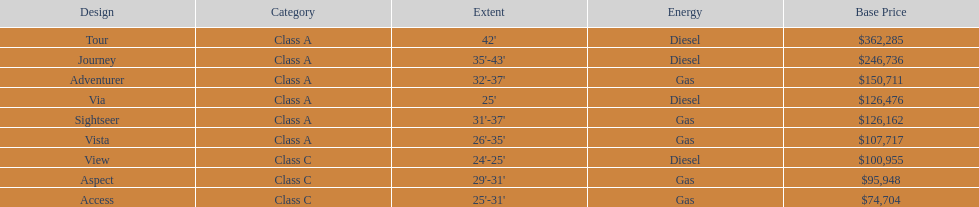Parse the full table. {'header': ['Design', 'Category', 'Extent', 'Energy', 'Base Price'], 'rows': [['Tour', 'Class A', "42'", 'Diesel', '$362,285'], ['Journey', 'Class A', "35'-43'", 'Diesel', '$246,736'], ['Adventurer', 'Class A', "32'-37'", 'Gas', '$150,711'], ['Via', 'Class A', "25'", 'Diesel', '$126,476'], ['Sightseer', 'Class A', "31'-37'", 'Gas', '$126,162'], ['Vista', 'Class A', "26'-35'", 'Gas', '$107,717'], ['View', 'Class C', "24'-25'", 'Diesel', '$100,955'], ['Aspect', 'Class C', "29'-31'", 'Gas', '$95,948'], ['Access', 'Class C', "25'-31'", 'Gas', '$74,704']]} How long is the aspect? 29'-31'. 